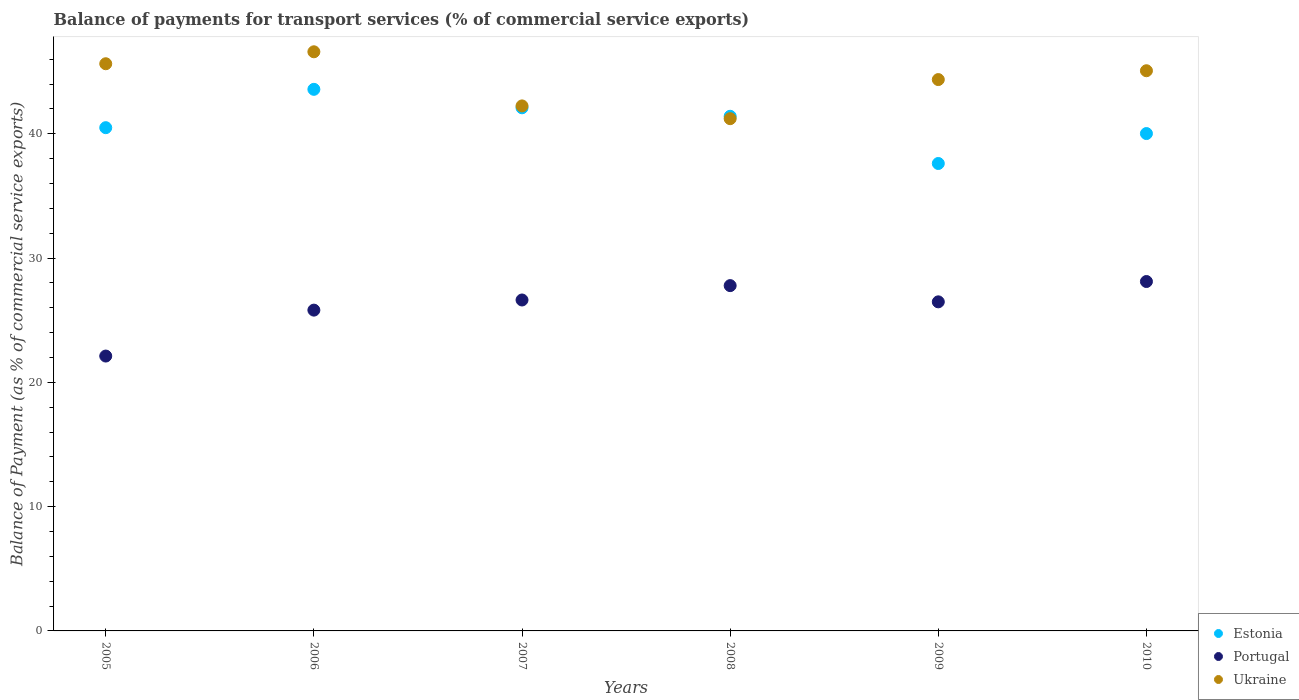What is the balance of payments for transport services in Ukraine in 2007?
Provide a short and direct response. 42.24. Across all years, what is the maximum balance of payments for transport services in Portugal?
Your response must be concise. 28.11. Across all years, what is the minimum balance of payments for transport services in Portugal?
Make the answer very short. 22.12. In which year was the balance of payments for transport services in Estonia minimum?
Offer a terse response. 2009. What is the total balance of payments for transport services in Ukraine in the graph?
Provide a short and direct response. 265.13. What is the difference between the balance of payments for transport services in Portugal in 2005 and that in 2007?
Make the answer very short. -4.51. What is the difference between the balance of payments for transport services in Estonia in 2007 and the balance of payments for transport services in Ukraine in 2010?
Offer a terse response. -2.98. What is the average balance of payments for transport services in Estonia per year?
Your response must be concise. 40.87. In the year 2010, what is the difference between the balance of payments for transport services in Portugal and balance of payments for transport services in Estonia?
Keep it short and to the point. -11.91. In how many years, is the balance of payments for transport services in Ukraine greater than 4 %?
Keep it short and to the point. 6. What is the ratio of the balance of payments for transport services in Ukraine in 2009 to that in 2010?
Keep it short and to the point. 0.98. Is the balance of payments for transport services in Ukraine in 2009 less than that in 2010?
Ensure brevity in your answer.  Yes. Is the difference between the balance of payments for transport services in Portugal in 2006 and 2010 greater than the difference between the balance of payments for transport services in Estonia in 2006 and 2010?
Your answer should be very brief. No. What is the difference between the highest and the second highest balance of payments for transport services in Estonia?
Give a very brief answer. 1.49. What is the difference between the highest and the lowest balance of payments for transport services in Estonia?
Your response must be concise. 5.97. Is it the case that in every year, the sum of the balance of payments for transport services in Estonia and balance of payments for transport services in Ukraine  is greater than the balance of payments for transport services in Portugal?
Keep it short and to the point. Yes. Does the balance of payments for transport services in Portugal monotonically increase over the years?
Give a very brief answer. No. How many dotlines are there?
Your answer should be compact. 3. How many years are there in the graph?
Keep it short and to the point. 6. Does the graph contain grids?
Give a very brief answer. No. What is the title of the graph?
Keep it short and to the point. Balance of payments for transport services (% of commercial service exports). Does "Brazil" appear as one of the legend labels in the graph?
Ensure brevity in your answer.  No. What is the label or title of the X-axis?
Keep it short and to the point. Years. What is the label or title of the Y-axis?
Make the answer very short. Balance of Payment (as % of commercial service exports). What is the Balance of Payment (as % of commercial service exports) in Estonia in 2005?
Ensure brevity in your answer.  40.49. What is the Balance of Payment (as % of commercial service exports) in Portugal in 2005?
Keep it short and to the point. 22.12. What is the Balance of Payment (as % of commercial service exports) in Ukraine in 2005?
Make the answer very short. 45.64. What is the Balance of Payment (as % of commercial service exports) of Estonia in 2006?
Provide a succinct answer. 43.58. What is the Balance of Payment (as % of commercial service exports) of Portugal in 2006?
Offer a very short reply. 25.81. What is the Balance of Payment (as % of commercial service exports) in Ukraine in 2006?
Your answer should be compact. 46.6. What is the Balance of Payment (as % of commercial service exports) of Estonia in 2007?
Your answer should be compact. 42.09. What is the Balance of Payment (as % of commercial service exports) in Portugal in 2007?
Offer a very short reply. 26.63. What is the Balance of Payment (as % of commercial service exports) in Ukraine in 2007?
Provide a succinct answer. 42.24. What is the Balance of Payment (as % of commercial service exports) in Estonia in 2008?
Give a very brief answer. 41.41. What is the Balance of Payment (as % of commercial service exports) of Portugal in 2008?
Your answer should be compact. 27.78. What is the Balance of Payment (as % of commercial service exports) of Ukraine in 2008?
Keep it short and to the point. 41.22. What is the Balance of Payment (as % of commercial service exports) in Estonia in 2009?
Keep it short and to the point. 37.61. What is the Balance of Payment (as % of commercial service exports) in Portugal in 2009?
Your answer should be very brief. 26.48. What is the Balance of Payment (as % of commercial service exports) of Ukraine in 2009?
Keep it short and to the point. 44.36. What is the Balance of Payment (as % of commercial service exports) in Estonia in 2010?
Keep it short and to the point. 40.02. What is the Balance of Payment (as % of commercial service exports) in Portugal in 2010?
Offer a terse response. 28.11. What is the Balance of Payment (as % of commercial service exports) in Ukraine in 2010?
Your response must be concise. 45.07. Across all years, what is the maximum Balance of Payment (as % of commercial service exports) of Estonia?
Your response must be concise. 43.58. Across all years, what is the maximum Balance of Payment (as % of commercial service exports) of Portugal?
Your answer should be very brief. 28.11. Across all years, what is the maximum Balance of Payment (as % of commercial service exports) in Ukraine?
Keep it short and to the point. 46.6. Across all years, what is the minimum Balance of Payment (as % of commercial service exports) in Estonia?
Your response must be concise. 37.61. Across all years, what is the minimum Balance of Payment (as % of commercial service exports) of Portugal?
Offer a terse response. 22.12. Across all years, what is the minimum Balance of Payment (as % of commercial service exports) in Ukraine?
Offer a terse response. 41.22. What is the total Balance of Payment (as % of commercial service exports) of Estonia in the graph?
Offer a very short reply. 245.2. What is the total Balance of Payment (as % of commercial service exports) of Portugal in the graph?
Ensure brevity in your answer.  156.93. What is the total Balance of Payment (as % of commercial service exports) in Ukraine in the graph?
Offer a very short reply. 265.13. What is the difference between the Balance of Payment (as % of commercial service exports) of Estonia in 2005 and that in 2006?
Make the answer very short. -3.09. What is the difference between the Balance of Payment (as % of commercial service exports) of Portugal in 2005 and that in 2006?
Offer a terse response. -3.7. What is the difference between the Balance of Payment (as % of commercial service exports) in Ukraine in 2005 and that in 2006?
Offer a terse response. -0.96. What is the difference between the Balance of Payment (as % of commercial service exports) in Estonia in 2005 and that in 2007?
Provide a succinct answer. -1.6. What is the difference between the Balance of Payment (as % of commercial service exports) of Portugal in 2005 and that in 2007?
Make the answer very short. -4.51. What is the difference between the Balance of Payment (as % of commercial service exports) of Ukraine in 2005 and that in 2007?
Keep it short and to the point. 3.39. What is the difference between the Balance of Payment (as % of commercial service exports) in Estonia in 2005 and that in 2008?
Your answer should be very brief. -0.92. What is the difference between the Balance of Payment (as % of commercial service exports) in Portugal in 2005 and that in 2008?
Ensure brevity in your answer.  -5.67. What is the difference between the Balance of Payment (as % of commercial service exports) in Ukraine in 2005 and that in 2008?
Your answer should be compact. 4.42. What is the difference between the Balance of Payment (as % of commercial service exports) in Estonia in 2005 and that in 2009?
Give a very brief answer. 2.88. What is the difference between the Balance of Payment (as % of commercial service exports) of Portugal in 2005 and that in 2009?
Keep it short and to the point. -4.36. What is the difference between the Balance of Payment (as % of commercial service exports) of Ukraine in 2005 and that in 2009?
Your answer should be compact. 1.27. What is the difference between the Balance of Payment (as % of commercial service exports) in Estonia in 2005 and that in 2010?
Your answer should be very brief. 0.47. What is the difference between the Balance of Payment (as % of commercial service exports) in Portugal in 2005 and that in 2010?
Offer a very short reply. -6. What is the difference between the Balance of Payment (as % of commercial service exports) in Ukraine in 2005 and that in 2010?
Give a very brief answer. 0.56. What is the difference between the Balance of Payment (as % of commercial service exports) of Estonia in 2006 and that in 2007?
Keep it short and to the point. 1.49. What is the difference between the Balance of Payment (as % of commercial service exports) of Portugal in 2006 and that in 2007?
Your answer should be very brief. -0.82. What is the difference between the Balance of Payment (as % of commercial service exports) of Ukraine in 2006 and that in 2007?
Offer a very short reply. 4.36. What is the difference between the Balance of Payment (as % of commercial service exports) of Estonia in 2006 and that in 2008?
Keep it short and to the point. 2.17. What is the difference between the Balance of Payment (as % of commercial service exports) in Portugal in 2006 and that in 2008?
Your response must be concise. -1.97. What is the difference between the Balance of Payment (as % of commercial service exports) of Ukraine in 2006 and that in 2008?
Provide a short and direct response. 5.38. What is the difference between the Balance of Payment (as % of commercial service exports) in Estonia in 2006 and that in 2009?
Your answer should be very brief. 5.97. What is the difference between the Balance of Payment (as % of commercial service exports) of Portugal in 2006 and that in 2009?
Give a very brief answer. -0.67. What is the difference between the Balance of Payment (as % of commercial service exports) of Ukraine in 2006 and that in 2009?
Provide a succinct answer. 2.24. What is the difference between the Balance of Payment (as % of commercial service exports) in Estonia in 2006 and that in 2010?
Keep it short and to the point. 3.56. What is the difference between the Balance of Payment (as % of commercial service exports) in Portugal in 2006 and that in 2010?
Ensure brevity in your answer.  -2.3. What is the difference between the Balance of Payment (as % of commercial service exports) of Ukraine in 2006 and that in 2010?
Offer a very short reply. 1.52. What is the difference between the Balance of Payment (as % of commercial service exports) of Estonia in 2007 and that in 2008?
Provide a short and direct response. 0.68. What is the difference between the Balance of Payment (as % of commercial service exports) of Portugal in 2007 and that in 2008?
Your answer should be compact. -1.16. What is the difference between the Balance of Payment (as % of commercial service exports) in Ukraine in 2007 and that in 2008?
Offer a terse response. 1.03. What is the difference between the Balance of Payment (as % of commercial service exports) in Estonia in 2007 and that in 2009?
Your answer should be compact. 4.48. What is the difference between the Balance of Payment (as % of commercial service exports) of Portugal in 2007 and that in 2009?
Provide a short and direct response. 0.15. What is the difference between the Balance of Payment (as % of commercial service exports) in Ukraine in 2007 and that in 2009?
Give a very brief answer. -2.12. What is the difference between the Balance of Payment (as % of commercial service exports) of Estonia in 2007 and that in 2010?
Your answer should be very brief. 2.07. What is the difference between the Balance of Payment (as % of commercial service exports) of Portugal in 2007 and that in 2010?
Make the answer very short. -1.49. What is the difference between the Balance of Payment (as % of commercial service exports) in Ukraine in 2007 and that in 2010?
Your answer should be very brief. -2.83. What is the difference between the Balance of Payment (as % of commercial service exports) of Estonia in 2008 and that in 2009?
Keep it short and to the point. 3.8. What is the difference between the Balance of Payment (as % of commercial service exports) in Portugal in 2008 and that in 2009?
Offer a terse response. 1.31. What is the difference between the Balance of Payment (as % of commercial service exports) in Ukraine in 2008 and that in 2009?
Give a very brief answer. -3.15. What is the difference between the Balance of Payment (as % of commercial service exports) of Estonia in 2008 and that in 2010?
Your answer should be compact. 1.39. What is the difference between the Balance of Payment (as % of commercial service exports) in Portugal in 2008 and that in 2010?
Your response must be concise. -0.33. What is the difference between the Balance of Payment (as % of commercial service exports) of Ukraine in 2008 and that in 2010?
Your answer should be compact. -3.86. What is the difference between the Balance of Payment (as % of commercial service exports) of Estonia in 2009 and that in 2010?
Your answer should be very brief. -2.41. What is the difference between the Balance of Payment (as % of commercial service exports) of Portugal in 2009 and that in 2010?
Your answer should be very brief. -1.64. What is the difference between the Balance of Payment (as % of commercial service exports) of Ukraine in 2009 and that in 2010?
Your response must be concise. -0.71. What is the difference between the Balance of Payment (as % of commercial service exports) in Estonia in 2005 and the Balance of Payment (as % of commercial service exports) in Portugal in 2006?
Make the answer very short. 14.68. What is the difference between the Balance of Payment (as % of commercial service exports) in Estonia in 2005 and the Balance of Payment (as % of commercial service exports) in Ukraine in 2006?
Your answer should be very brief. -6.11. What is the difference between the Balance of Payment (as % of commercial service exports) in Portugal in 2005 and the Balance of Payment (as % of commercial service exports) in Ukraine in 2006?
Offer a very short reply. -24.48. What is the difference between the Balance of Payment (as % of commercial service exports) in Estonia in 2005 and the Balance of Payment (as % of commercial service exports) in Portugal in 2007?
Ensure brevity in your answer.  13.86. What is the difference between the Balance of Payment (as % of commercial service exports) in Estonia in 2005 and the Balance of Payment (as % of commercial service exports) in Ukraine in 2007?
Make the answer very short. -1.75. What is the difference between the Balance of Payment (as % of commercial service exports) in Portugal in 2005 and the Balance of Payment (as % of commercial service exports) in Ukraine in 2007?
Offer a terse response. -20.13. What is the difference between the Balance of Payment (as % of commercial service exports) of Estonia in 2005 and the Balance of Payment (as % of commercial service exports) of Portugal in 2008?
Make the answer very short. 12.71. What is the difference between the Balance of Payment (as % of commercial service exports) in Estonia in 2005 and the Balance of Payment (as % of commercial service exports) in Ukraine in 2008?
Provide a short and direct response. -0.72. What is the difference between the Balance of Payment (as % of commercial service exports) of Portugal in 2005 and the Balance of Payment (as % of commercial service exports) of Ukraine in 2008?
Offer a terse response. -19.1. What is the difference between the Balance of Payment (as % of commercial service exports) of Estonia in 2005 and the Balance of Payment (as % of commercial service exports) of Portugal in 2009?
Your response must be concise. 14.01. What is the difference between the Balance of Payment (as % of commercial service exports) in Estonia in 2005 and the Balance of Payment (as % of commercial service exports) in Ukraine in 2009?
Give a very brief answer. -3.87. What is the difference between the Balance of Payment (as % of commercial service exports) in Portugal in 2005 and the Balance of Payment (as % of commercial service exports) in Ukraine in 2009?
Keep it short and to the point. -22.25. What is the difference between the Balance of Payment (as % of commercial service exports) in Estonia in 2005 and the Balance of Payment (as % of commercial service exports) in Portugal in 2010?
Your response must be concise. 12.38. What is the difference between the Balance of Payment (as % of commercial service exports) of Estonia in 2005 and the Balance of Payment (as % of commercial service exports) of Ukraine in 2010?
Your response must be concise. -4.58. What is the difference between the Balance of Payment (as % of commercial service exports) of Portugal in 2005 and the Balance of Payment (as % of commercial service exports) of Ukraine in 2010?
Your response must be concise. -22.96. What is the difference between the Balance of Payment (as % of commercial service exports) of Estonia in 2006 and the Balance of Payment (as % of commercial service exports) of Portugal in 2007?
Give a very brief answer. 16.95. What is the difference between the Balance of Payment (as % of commercial service exports) in Estonia in 2006 and the Balance of Payment (as % of commercial service exports) in Ukraine in 2007?
Your answer should be very brief. 1.33. What is the difference between the Balance of Payment (as % of commercial service exports) in Portugal in 2006 and the Balance of Payment (as % of commercial service exports) in Ukraine in 2007?
Offer a terse response. -16.43. What is the difference between the Balance of Payment (as % of commercial service exports) of Estonia in 2006 and the Balance of Payment (as % of commercial service exports) of Portugal in 2008?
Your response must be concise. 15.79. What is the difference between the Balance of Payment (as % of commercial service exports) of Estonia in 2006 and the Balance of Payment (as % of commercial service exports) of Ukraine in 2008?
Offer a very short reply. 2.36. What is the difference between the Balance of Payment (as % of commercial service exports) in Portugal in 2006 and the Balance of Payment (as % of commercial service exports) in Ukraine in 2008?
Give a very brief answer. -15.4. What is the difference between the Balance of Payment (as % of commercial service exports) in Estonia in 2006 and the Balance of Payment (as % of commercial service exports) in Portugal in 2009?
Your answer should be compact. 17.1. What is the difference between the Balance of Payment (as % of commercial service exports) in Estonia in 2006 and the Balance of Payment (as % of commercial service exports) in Ukraine in 2009?
Ensure brevity in your answer.  -0.78. What is the difference between the Balance of Payment (as % of commercial service exports) of Portugal in 2006 and the Balance of Payment (as % of commercial service exports) of Ukraine in 2009?
Make the answer very short. -18.55. What is the difference between the Balance of Payment (as % of commercial service exports) of Estonia in 2006 and the Balance of Payment (as % of commercial service exports) of Portugal in 2010?
Give a very brief answer. 15.46. What is the difference between the Balance of Payment (as % of commercial service exports) of Estonia in 2006 and the Balance of Payment (as % of commercial service exports) of Ukraine in 2010?
Give a very brief answer. -1.5. What is the difference between the Balance of Payment (as % of commercial service exports) of Portugal in 2006 and the Balance of Payment (as % of commercial service exports) of Ukraine in 2010?
Keep it short and to the point. -19.26. What is the difference between the Balance of Payment (as % of commercial service exports) in Estonia in 2007 and the Balance of Payment (as % of commercial service exports) in Portugal in 2008?
Make the answer very short. 14.31. What is the difference between the Balance of Payment (as % of commercial service exports) of Estonia in 2007 and the Balance of Payment (as % of commercial service exports) of Ukraine in 2008?
Provide a succinct answer. 0.88. What is the difference between the Balance of Payment (as % of commercial service exports) in Portugal in 2007 and the Balance of Payment (as % of commercial service exports) in Ukraine in 2008?
Offer a terse response. -14.59. What is the difference between the Balance of Payment (as % of commercial service exports) of Estonia in 2007 and the Balance of Payment (as % of commercial service exports) of Portugal in 2009?
Provide a short and direct response. 15.61. What is the difference between the Balance of Payment (as % of commercial service exports) in Estonia in 2007 and the Balance of Payment (as % of commercial service exports) in Ukraine in 2009?
Ensure brevity in your answer.  -2.27. What is the difference between the Balance of Payment (as % of commercial service exports) of Portugal in 2007 and the Balance of Payment (as % of commercial service exports) of Ukraine in 2009?
Your answer should be compact. -17.73. What is the difference between the Balance of Payment (as % of commercial service exports) of Estonia in 2007 and the Balance of Payment (as % of commercial service exports) of Portugal in 2010?
Give a very brief answer. 13.98. What is the difference between the Balance of Payment (as % of commercial service exports) in Estonia in 2007 and the Balance of Payment (as % of commercial service exports) in Ukraine in 2010?
Make the answer very short. -2.98. What is the difference between the Balance of Payment (as % of commercial service exports) in Portugal in 2007 and the Balance of Payment (as % of commercial service exports) in Ukraine in 2010?
Ensure brevity in your answer.  -18.45. What is the difference between the Balance of Payment (as % of commercial service exports) of Estonia in 2008 and the Balance of Payment (as % of commercial service exports) of Portugal in 2009?
Your response must be concise. 14.93. What is the difference between the Balance of Payment (as % of commercial service exports) of Estonia in 2008 and the Balance of Payment (as % of commercial service exports) of Ukraine in 2009?
Provide a succinct answer. -2.95. What is the difference between the Balance of Payment (as % of commercial service exports) of Portugal in 2008 and the Balance of Payment (as % of commercial service exports) of Ukraine in 2009?
Keep it short and to the point. -16.58. What is the difference between the Balance of Payment (as % of commercial service exports) of Estonia in 2008 and the Balance of Payment (as % of commercial service exports) of Portugal in 2010?
Give a very brief answer. 13.29. What is the difference between the Balance of Payment (as % of commercial service exports) in Estonia in 2008 and the Balance of Payment (as % of commercial service exports) in Ukraine in 2010?
Provide a short and direct response. -3.66. What is the difference between the Balance of Payment (as % of commercial service exports) of Portugal in 2008 and the Balance of Payment (as % of commercial service exports) of Ukraine in 2010?
Your answer should be very brief. -17.29. What is the difference between the Balance of Payment (as % of commercial service exports) of Estonia in 2009 and the Balance of Payment (as % of commercial service exports) of Portugal in 2010?
Offer a terse response. 9.5. What is the difference between the Balance of Payment (as % of commercial service exports) in Estonia in 2009 and the Balance of Payment (as % of commercial service exports) in Ukraine in 2010?
Keep it short and to the point. -7.46. What is the difference between the Balance of Payment (as % of commercial service exports) of Portugal in 2009 and the Balance of Payment (as % of commercial service exports) of Ukraine in 2010?
Your response must be concise. -18.59. What is the average Balance of Payment (as % of commercial service exports) of Estonia per year?
Offer a terse response. 40.87. What is the average Balance of Payment (as % of commercial service exports) in Portugal per year?
Offer a terse response. 26.16. What is the average Balance of Payment (as % of commercial service exports) in Ukraine per year?
Offer a terse response. 44.19. In the year 2005, what is the difference between the Balance of Payment (as % of commercial service exports) of Estonia and Balance of Payment (as % of commercial service exports) of Portugal?
Provide a short and direct response. 18.38. In the year 2005, what is the difference between the Balance of Payment (as % of commercial service exports) of Estonia and Balance of Payment (as % of commercial service exports) of Ukraine?
Offer a very short reply. -5.14. In the year 2005, what is the difference between the Balance of Payment (as % of commercial service exports) in Portugal and Balance of Payment (as % of commercial service exports) in Ukraine?
Offer a very short reply. -23.52. In the year 2006, what is the difference between the Balance of Payment (as % of commercial service exports) in Estonia and Balance of Payment (as % of commercial service exports) in Portugal?
Ensure brevity in your answer.  17.77. In the year 2006, what is the difference between the Balance of Payment (as % of commercial service exports) of Estonia and Balance of Payment (as % of commercial service exports) of Ukraine?
Your answer should be very brief. -3.02. In the year 2006, what is the difference between the Balance of Payment (as % of commercial service exports) of Portugal and Balance of Payment (as % of commercial service exports) of Ukraine?
Give a very brief answer. -20.79. In the year 2007, what is the difference between the Balance of Payment (as % of commercial service exports) in Estonia and Balance of Payment (as % of commercial service exports) in Portugal?
Keep it short and to the point. 15.46. In the year 2007, what is the difference between the Balance of Payment (as % of commercial service exports) of Estonia and Balance of Payment (as % of commercial service exports) of Ukraine?
Ensure brevity in your answer.  -0.15. In the year 2007, what is the difference between the Balance of Payment (as % of commercial service exports) in Portugal and Balance of Payment (as % of commercial service exports) in Ukraine?
Provide a short and direct response. -15.61. In the year 2008, what is the difference between the Balance of Payment (as % of commercial service exports) of Estonia and Balance of Payment (as % of commercial service exports) of Portugal?
Ensure brevity in your answer.  13.62. In the year 2008, what is the difference between the Balance of Payment (as % of commercial service exports) of Estonia and Balance of Payment (as % of commercial service exports) of Ukraine?
Offer a terse response. 0.19. In the year 2008, what is the difference between the Balance of Payment (as % of commercial service exports) of Portugal and Balance of Payment (as % of commercial service exports) of Ukraine?
Give a very brief answer. -13.43. In the year 2009, what is the difference between the Balance of Payment (as % of commercial service exports) in Estonia and Balance of Payment (as % of commercial service exports) in Portugal?
Provide a succinct answer. 11.13. In the year 2009, what is the difference between the Balance of Payment (as % of commercial service exports) of Estonia and Balance of Payment (as % of commercial service exports) of Ukraine?
Your answer should be compact. -6.75. In the year 2009, what is the difference between the Balance of Payment (as % of commercial service exports) of Portugal and Balance of Payment (as % of commercial service exports) of Ukraine?
Keep it short and to the point. -17.88. In the year 2010, what is the difference between the Balance of Payment (as % of commercial service exports) of Estonia and Balance of Payment (as % of commercial service exports) of Portugal?
Keep it short and to the point. 11.91. In the year 2010, what is the difference between the Balance of Payment (as % of commercial service exports) of Estonia and Balance of Payment (as % of commercial service exports) of Ukraine?
Your answer should be compact. -5.05. In the year 2010, what is the difference between the Balance of Payment (as % of commercial service exports) of Portugal and Balance of Payment (as % of commercial service exports) of Ukraine?
Offer a very short reply. -16.96. What is the ratio of the Balance of Payment (as % of commercial service exports) in Estonia in 2005 to that in 2006?
Your response must be concise. 0.93. What is the ratio of the Balance of Payment (as % of commercial service exports) in Portugal in 2005 to that in 2006?
Ensure brevity in your answer.  0.86. What is the ratio of the Balance of Payment (as % of commercial service exports) of Ukraine in 2005 to that in 2006?
Offer a terse response. 0.98. What is the ratio of the Balance of Payment (as % of commercial service exports) of Estonia in 2005 to that in 2007?
Provide a short and direct response. 0.96. What is the ratio of the Balance of Payment (as % of commercial service exports) in Portugal in 2005 to that in 2007?
Provide a short and direct response. 0.83. What is the ratio of the Balance of Payment (as % of commercial service exports) in Ukraine in 2005 to that in 2007?
Provide a succinct answer. 1.08. What is the ratio of the Balance of Payment (as % of commercial service exports) of Estonia in 2005 to that in 2008?
Ensure brevity in your answer.  0.98. What is the ratio of the Balance of Payment (as % of commercial service exports) in Portugal in 2005 to that in 2008?
Your answer should be very brief. 0.8. What is the ratio of the Balance of Payment (as % of commercial service exports) of Ukraine in 2005 to that in 2008?
Offer a terse response. 1.11. What is the ratio of the Balance of Payment (as % of commercial service exports) in Estonia in 2005 to that in 2009?
Keep it short and to the point. 1.08. What is the ratio of the Balance of Payment (as % of commercial service exports) in Portugal in 2005 to that in 2009?
Ensure brevity in your answer.  0.84. What is the ratio of the Balance of Payment (as % of commercial service exports) in Ukraine in 2005 to that in 2009?
Offer a very short reply. 1.03. What is the ratio of the Balance of Payment (as % of commercial service exports) in Estonia in 2005 to that in 2010?
Your response must be concise. 1.01. What is the ratio of the Balance of Payment (as % of commercial service exports) in Portugal in 2005 to that in 2010?
Provide a short and direct response. 0.79. What is the ratio of the Balance of Payment (as % of commercial service exports) of Ukraine in 2005 to that in 2010?
Give a very brief answer. 1.01. What is the ratio of the Balance of Payment (as % of commercial service exports) of Estonia in 2006 to that in 2007?
Make the answer very short. 1.04. What is the ratio of the Balance of Payment (as % of commercial service exports) of Portugal in 2006 to that in 2007?
Your response must be concise. 0.97. What is the ratio of the Balance of Payment (as % of commercial service exports) in Ukraine in 2006 to that in 2007?
Keep it short and to the point. 1.1. What is the ratio of the Balance of Payment (as % of commercial service exports) in Estonia in 2006 to that in 2008?
Your response must be concise. 1.05. What is the ratio of the Balance of Payment (as % of commercial service exports) in Portugal in 2006 to that in 2008?
Provide a succinct answer. 0.93. What is the ratio of the Balance of Payment (as % of commercial service exports) of Ukraine in 2006 to that in 2008?
Provide a succinct answer. 1.13. What is the ratio of the Balance of Payment (as % of commercial service exports) of Estonia in 2006 to that in 2009?
Provide a succinct answer. 1.16. What is the ratio of the Balance of Payment (as % of commercial service exports) of Portugal in 2006 to that in 2009?
Make the answer very short. 0.97. What is the ratio of the Balance of Payment (as % of commercial service exports) of Ukraine in 2006 to that in 2009?
Provide a succinct answer. 1.05. What is the ratio of the Balance of Payment (as % of commercial service exports) in Estonia in 2006 to that in 2010?
Ensure brevity in your answer.  1.09. What is the ratio of the Balance of Payment (as % of commercial service exports) in Portugal in 2006 to that in 2010?
Your answer should be compact. 0.92. What is the ratio of the Balance of Payment (as % of commercial service exports) of Ukraine in 2006 to that in 2010?
Your answer should be very brief. 1.03. What is the ratio of the Balance of Payment (as % of commercial service exports) in Estonia in 2007 to that in 2008?
Offer a terse response. 1.02. What is the ratio of the Balance of Payment (as % of commercial service exports) of Portugal in 2007 to that in 2008?
Your answer should be compact. 0.96. What is the ratio of the Balance of Payment (as % of commercial service exports) in Ukraine in 2007 to that in 2008?
Offer a very short reply. 1.02. What is the ratio of the Balance of Payment (as % of commercial service exports) of Estonia in 2007 to that in 2009?
Offer a terse response. 1.12. What is the ratio of the Balance of Payment (as % of commercial service exports) in Portugal in 2007 to that in 2009?
Ensure brevity in your answer.  1.01. What is the ratio of the Balance of Payment (as % of commercial service exports) in Ukraine in 2007 to that in 2009?
Offer a very short reply. 0.95. What is the ratio of the Balance of Payment (as % of commercial service exports) of Estonia in 2007 to that in 2010?
Your answer should be very brief. 1.05. What is the ratio of the Balance of Payment (as % of commercial service exports) of Portugal in 2007 to that in 2010?
Give a very brief answer. 0.95. What is the ratio of the Balance of Payment (as % of commercial service exports) of Ukraine in 2007 to that in 2010?
Offer a very short reply. 0.94. What is the ratio of the Balance of Payment (as % of commercial service exports) of Estonia in 2008 to that in 2009?
Provide a short and direct response. 1.1. What is the ratio of the Balance of Payment (as % of commercial service exports) in Portugal in 2008 to that in 2009?
Give a very brief answer. 1.05. What is the ratio of the Balance of Payment (as % of commercial service exports) in Ukraine in 2008 to that in 2009?
Provide a short and direct response. 0.93. What is the ratio of the Balance of Payment (as % of commercial service exports) of Estonia in 2008 to that in 2010?
Provide a succinct answer. 1.03. What is the ratio of the Balance of Payment (as % of commercial service exports) in Portugal in 2008 to that in 2010?
Make the answer very short. 0.99. What is the ratio of the Balance of Payment (as % of commercial service exports) of Ukraine in 2008 to that in 2010?
Your answer should be very brief. 0.91. What is the ratio of the Balance of Payment (as % of commercial service exports) in Estonia in 2009 to that in 2010?
Offer a very short reply. 0.94. What is the ratio of the Balance of Payment (as % of commercial service exports) in Portugal in 2009 to that in 2010?
Provide a short and direct response. 0.94. What is the ratio of the Balance of Payment (as % of commercial service exports) of Ukraine in 2009 to that in 2010?
Provide a short and direct response. 0.98. What is the difference between the highest and the second highest Balance of Payment (as % of commercial service exports) in Estonia?
Offer a very short reply. 1.49. What is the difference between the highest and the second highest Balance of Payment (as % of commercial service exports) in Portugal?
Your answer should be very brief. 0.33. What is the difference between the highest and the second highest Balance of Payment (as % of commercial service exports) in Ukraine?
Offer a terse response. 0.96. What is the difference between the highest and the lowest Balance of Payment (as % of commercial service exports) in Estonia?
Ensure brevity in your answer.  5.97. What is the difference between the highest and the lowest Balance of Payment (as % of commercial service exports) of Portugal?
Give a very brief answer. 6. What is the difference between the highest and the lowest Balance of Payment (as % of commercial service exports) in Ukraine?
Make the answer very short. 5.38. 